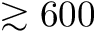<formula> <loc_0><loc_0><loc_500><loc_500>\gtrsim 6 0 0</formula> 